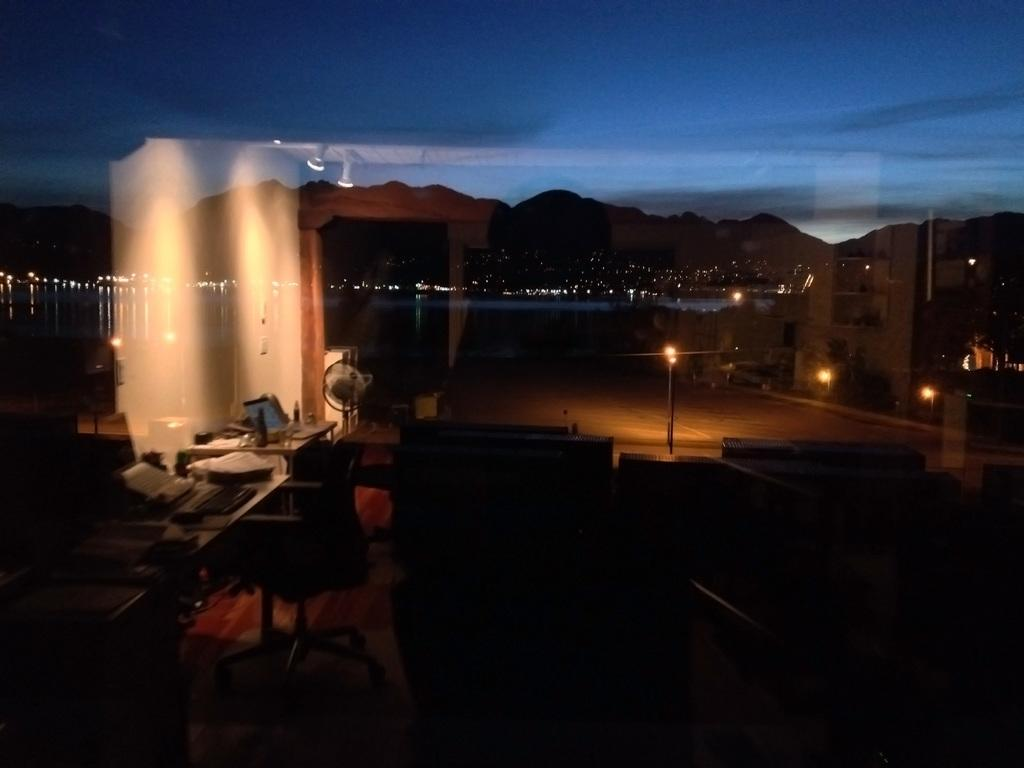What type of furniture is present in the image? There are tables and chairs in the image. What can be found on the tables? Bottles are present on the tables in the image. What type of illumination is visible in the image? There are lights in the image. What type of natural scenery is visible in the image? There are mountains in the image. What other objects can be seen in the image? There are other objects in the image, but their specific details are not mentioned in the provided facts. What is the texture of the unit in the image? There is no mention of a "unit" in the provided facts, so we cannot determine its texture. 